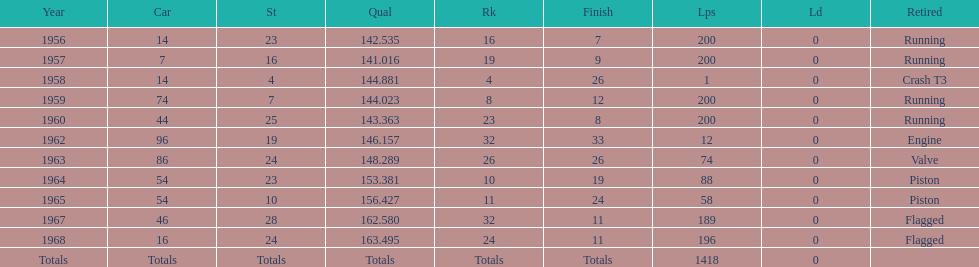Tell me the number of times he finished above 10th place. 3. 